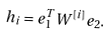Convert formula to latex. <formula><loc_0><loc_0><loc_500><loc_500>h _ { i } = e _ { 1 } ^ { T } W ^ { [ i ] } e _ { 2 } .</formula> 